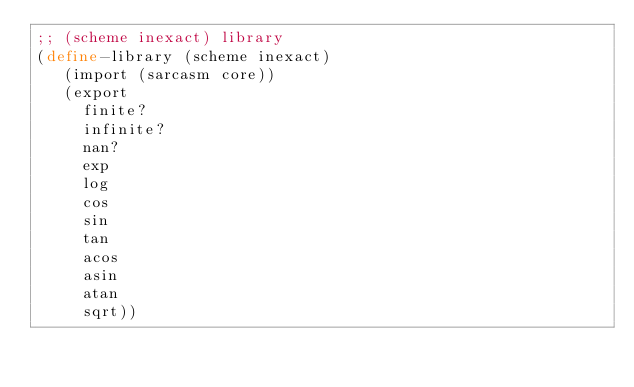<code> <loc_0><loc_0><loc_500><loc_500><_Scheme_>;; (scheme inexact) library
(define-library (scheme inexact)
   (import (sarcasm core))
   (export
     finite?
     infinite? 
     nan? 
     exp 
     log
     cos
     sin
     tan
     acos
     asin
     atan
     sqrt))

</code> 